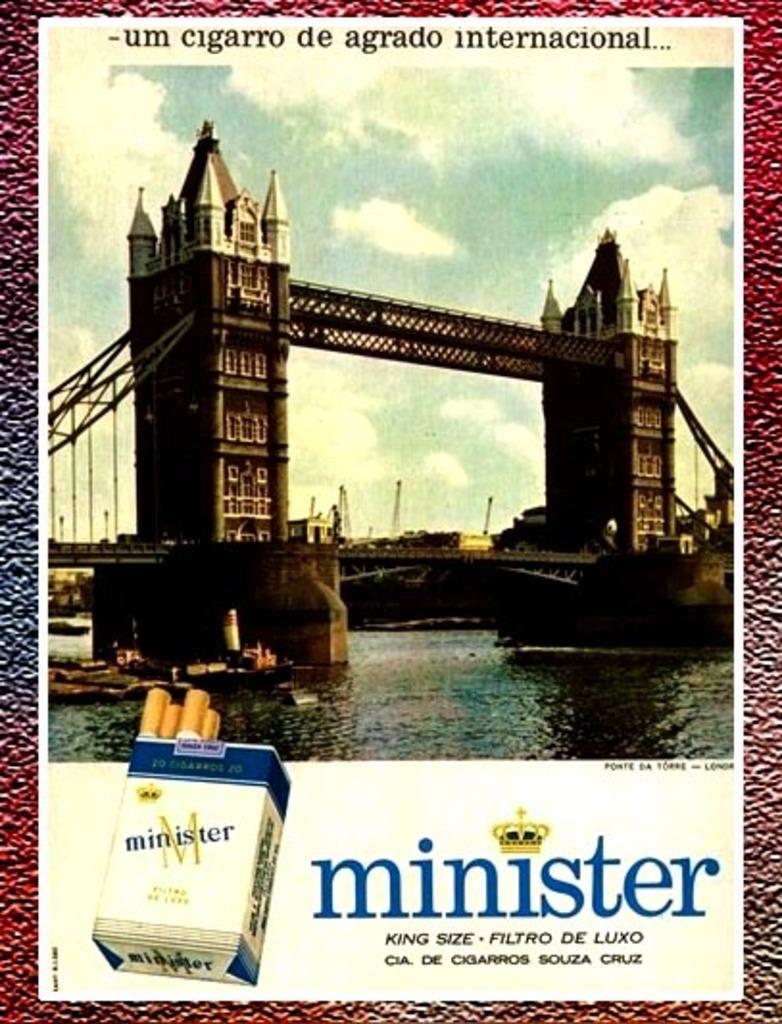<image>
Relay a brief, clear account of the picture shown. An ad for minister cigarettes shows a bridge and water on it. 